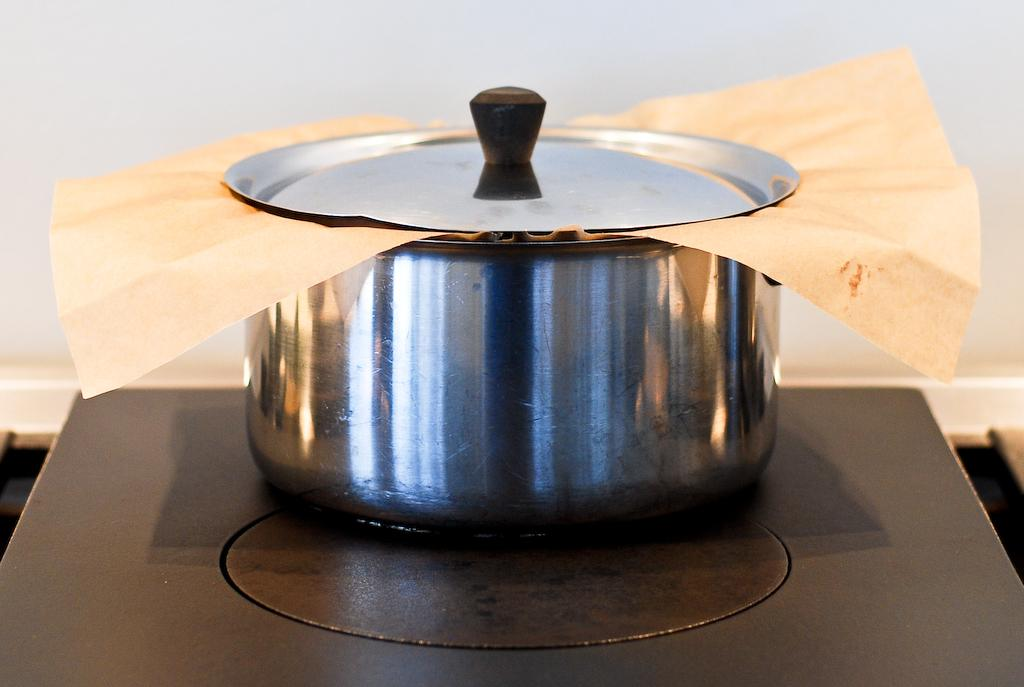What is the main object in the center of the image? There is a vessel in the center of the image. What is inside the vessel? The vessel contains paper. Where is the vessel located? The vessel is on a table. What can be seen in the background of the image? There is a wall in the background of the image. What type of bun can be seen on the table next to the vessel? There is no bun present on the table next to the vessel in the image. 